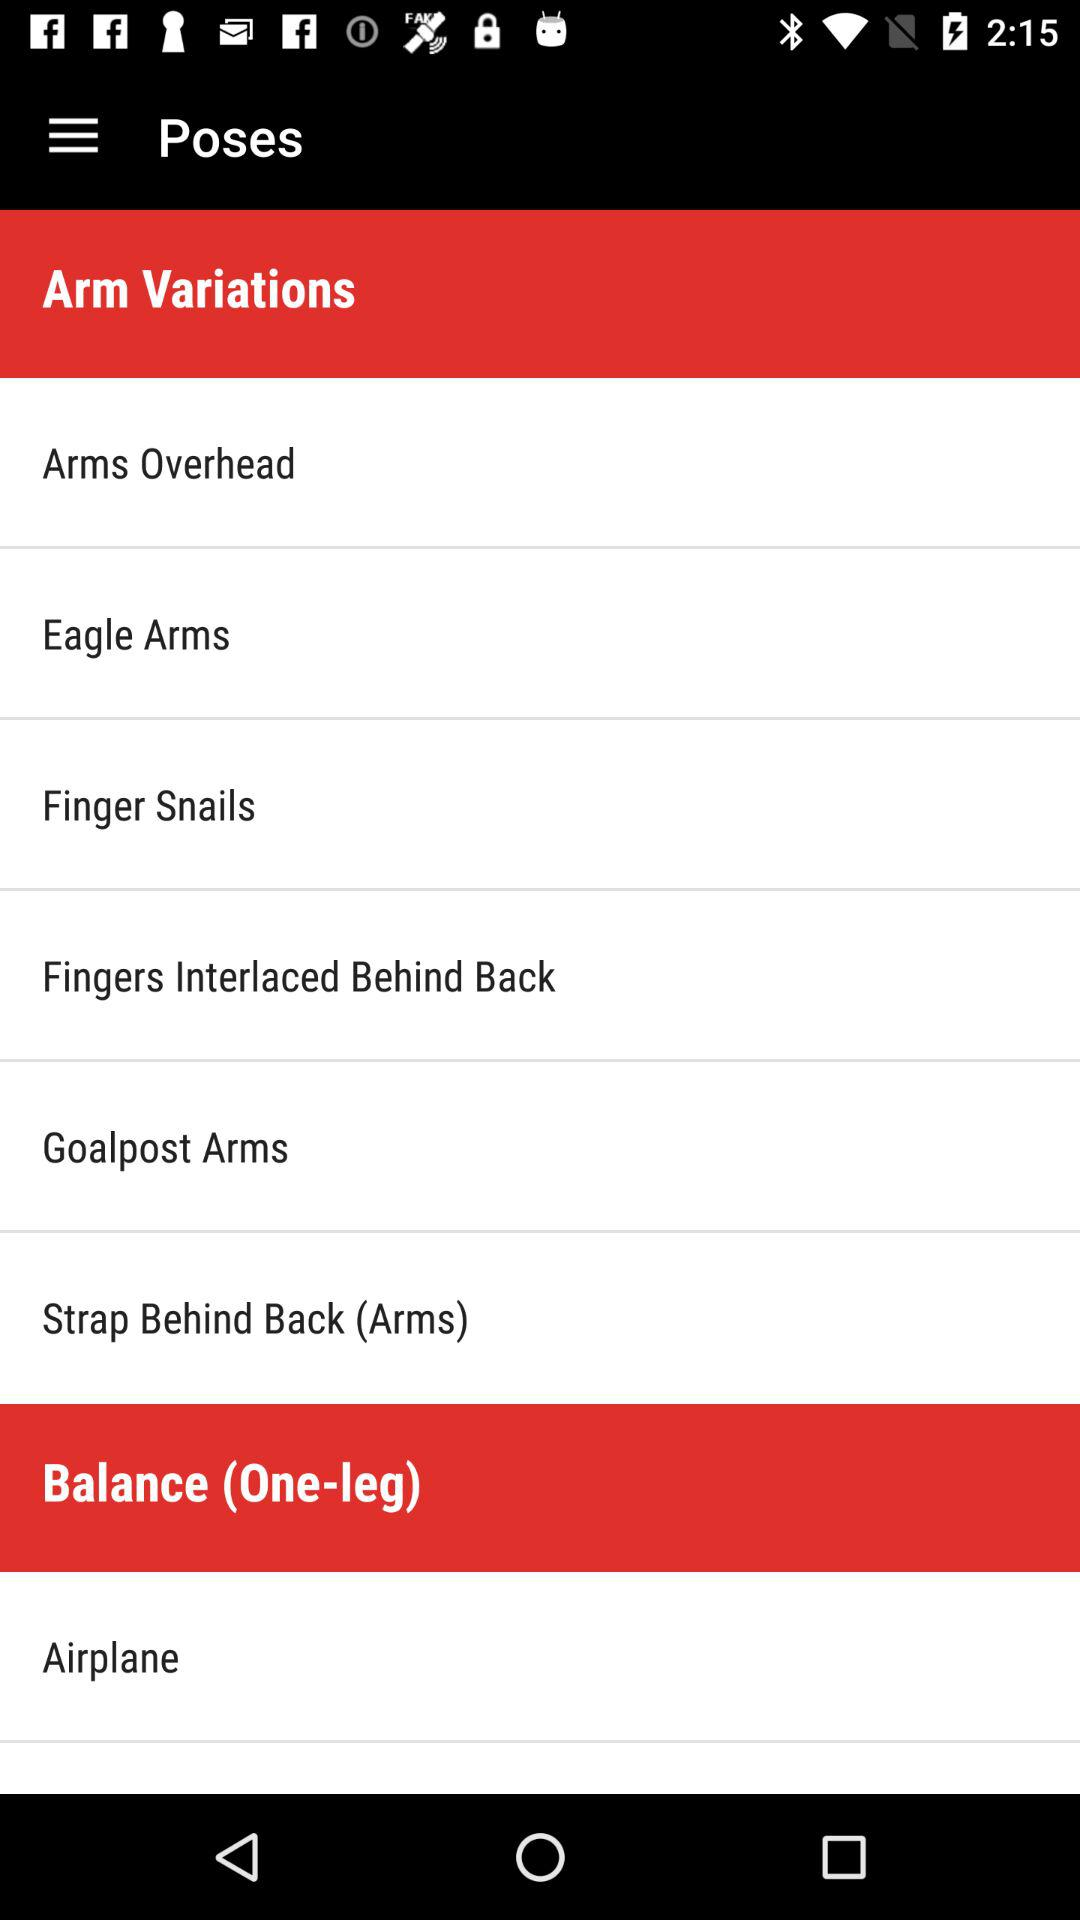What are the options available in "Arm Variations"? The available options are "Arms Overhead", "Eagle Arms", "Finger Snails", "Fingers Interlaced Behind Back", "Goalpost Arms" and "Strap Behind Back (Arms)". 